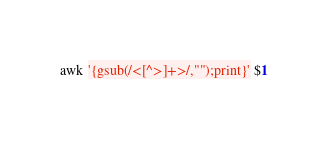<code> <loc_0><loc_0><loc_500><loc_500><_Awk_>awk '{gsub(/<[^>]+>/,"");print}' $1

</code> 